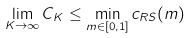<formula> <loc_0><loc_0><loc_500><loc_500>\lim _ { K \to \infty } C _ { K } \leq \min _ { m \in [ 0 , 1 ] } c _ { R S } ( m )</formula> 